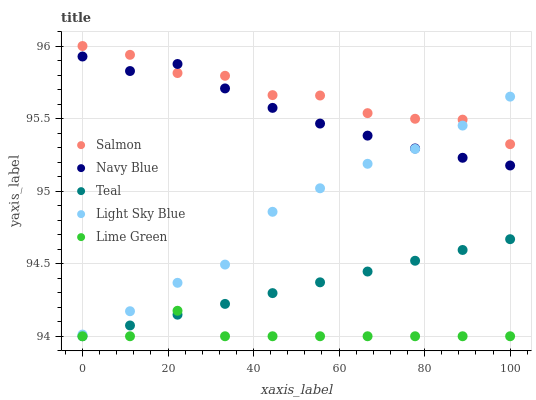Does Lime Green have the minimum area under the curve?
Answer yes or no. Yes. Does Salmon have the maximum area under the curve?
Answer yes or no. Yes. Does Navy Blue have the minimum area under the curve?
Answer yes or no. No. Does Navy Blue have the maximum area under the curve?
Answer yes or no. No. Is Teal the smoothest?
Answer yes or no. Yes. Is Salmon the roughest?
Answer yes or no. Yes. Is Navy Blue the smoothest?
Answer yes or no. No. Is Navy Blue the roughest?
Answer yes or no. No. Does Lime Green have the lowest value?
Answer yes or no. Yes. Does Navy Blue have the lowest value?
Answer yes or no. No. Does Salmon have the highest value?
Answer yes or no. Yes. Does Navy Blue have the highest value?
Answer yes or no. No. Is Teal less than Light Sky Blue?
Answer yes or no. Yes. Is Light Sky Blue greater than Lime Green?
Answer yes or no. Yes. Does Navy Blue intersect Salmon?
Answer yes or no. Yes. Is Navy Blue less than Salmon?
Answer yes or no. No. Is Navy Blue greater than Salmon?
Answer yes or no. No. Does Teal intersect Light Sky Blue?
Answer yes or no. No. 